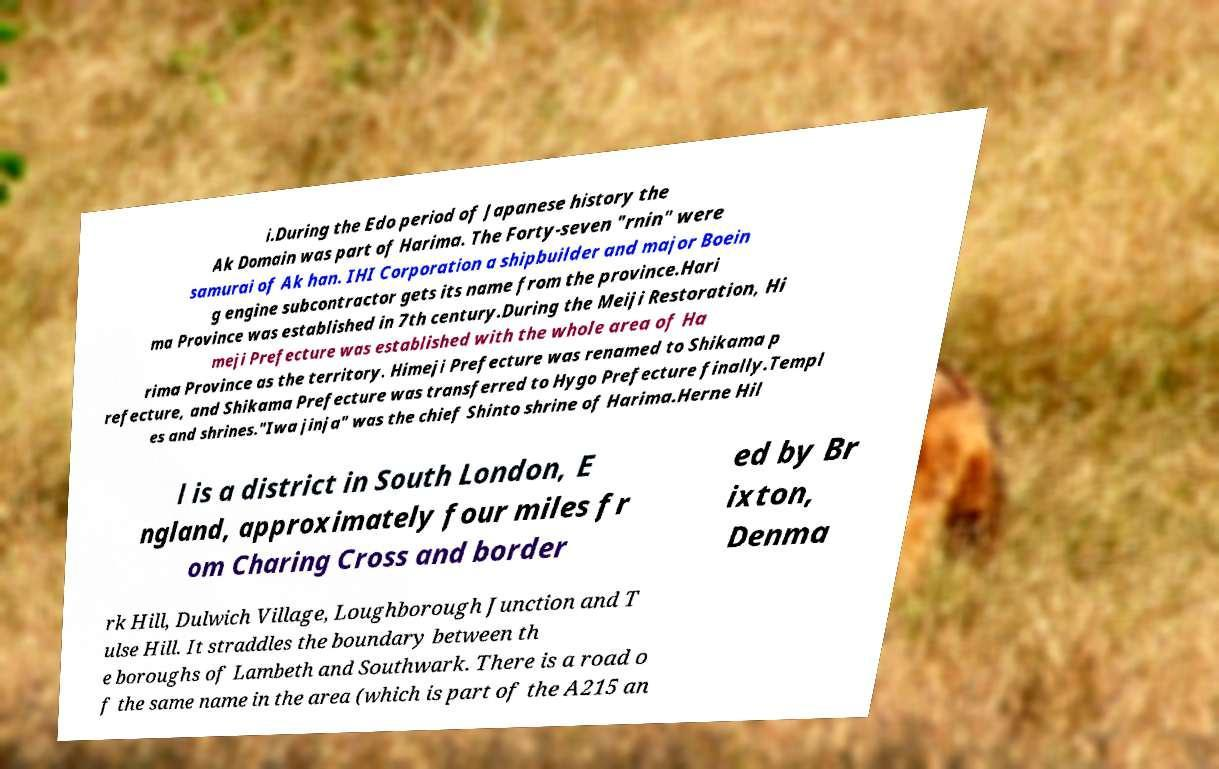Can you read and provide the text displayed in the image?This photo seems to have some interesting text. Can you extract and type it out for me? i.During the Edo period of Japanese history the Ak Domain was part of Harima. The Forty-seven "rnin" were samurai of Ak han. IHI Corporation a shipbuilder and major Boein g engine subcontractor gets its name from the province.Hari ma Province was established in 7th century.During the Meiji Restoration, Hi meji Prefecture was established with the whole area of Ha rima Province as the territory. Himeji Prefecture was renamed to Shikama p refecture, and Shikama Prefecture was transferred to Hygo Prefecture finally.Templ es and shrines."Iwa jinja" was the chief Shinto shrine of Harima.Herne Hil l is a district in South London, E ngland, approximately four miles fr om Charing Cross and border ed by Br ixton, Denma rk Hill, Dulwich Village, Loughborough Junction and T ulse Hill. It straddles the boundary between th e boroughs of Lambeth and Southwark. There is a road o f the same name in the area (which is part of the A215 an 